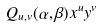<formula> <loc_0><loc_0><loc_500><loc_500>Q _ { u , v } ( \alpha , \beta ) x ^ { u } y ^ { v }</formula> 